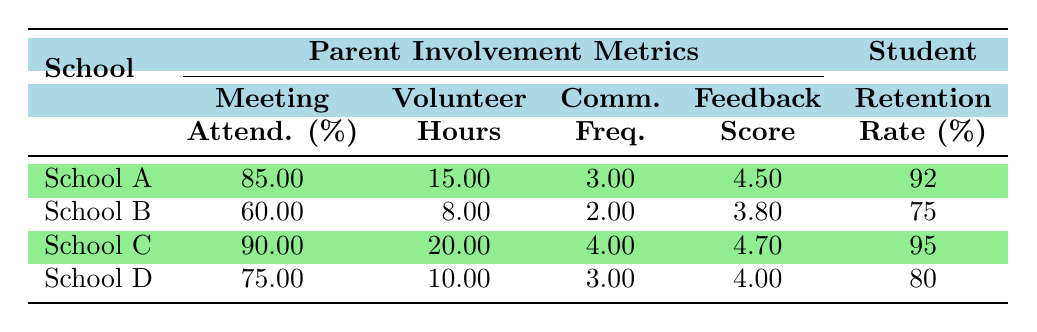What is the retention rate for School C? The table lists the retention rates for each school. For School C, the retention rate is directly shown as 95%.
Answer: 95 Which school has the lowest parent meeting attendance percentage? Looking at the table, School B has the lowest parent meeting attendance percentage at 60%.
Answer: 60 What is the average parent volunteer hours per month across all schools? To find the average, add the volunteer hours for each school: (15 + 8 + 20 + 10) = 53 hours. Then divide by the number of schools: 53 / 4 = 13.25 hours.
Answer: 13.25 Is the parent feedback survey score for School D higher than that of School B? By comparing the scores, School D has a score of 4.0, and School B has a score of 3.8. Since 4.0 is greater than 3.8, the answer is yes.
Answer: Yes What is the difference in retention rates between School A and School B? The retention rate for School A is 92% and for School B is 75%. Subtracting these gives 92 - 75 = 17%.
Answer: 17 Which school has the highest level of communication frequency with teachers? The table displays the communication frequency for each school; School C has the highest frequency with a score of 4.
Answer: School C Is there a correlation between higher parent volunteer hours and student retention rates in this table? Observing the data, School C with the highest volunteer hours (20) also has the highest retention rate (95). Since this pattern appears consistent with other schools as well, the answer is yes, they correlate.
Answer: Yes What is the total percentage of parent meeting attendance for all schools combined? To find this, add the meeting attendance percentages: 85 + 60 + 90 + 75 = 310%. The total is 310%.
Answer: 310 Which school had the highest retention rate? By checking the retention rates in the table, School C shows the highest rate at 95%.
Answer: School C What is the average parent feedback survey score for the schools? Adding the scores gives: (4.5 + 3.8 + 4.7 + 4.0) = 17.0. Dividing by the number of schools: 17.0 / 4 = 4.25.
Answer: 4.25 